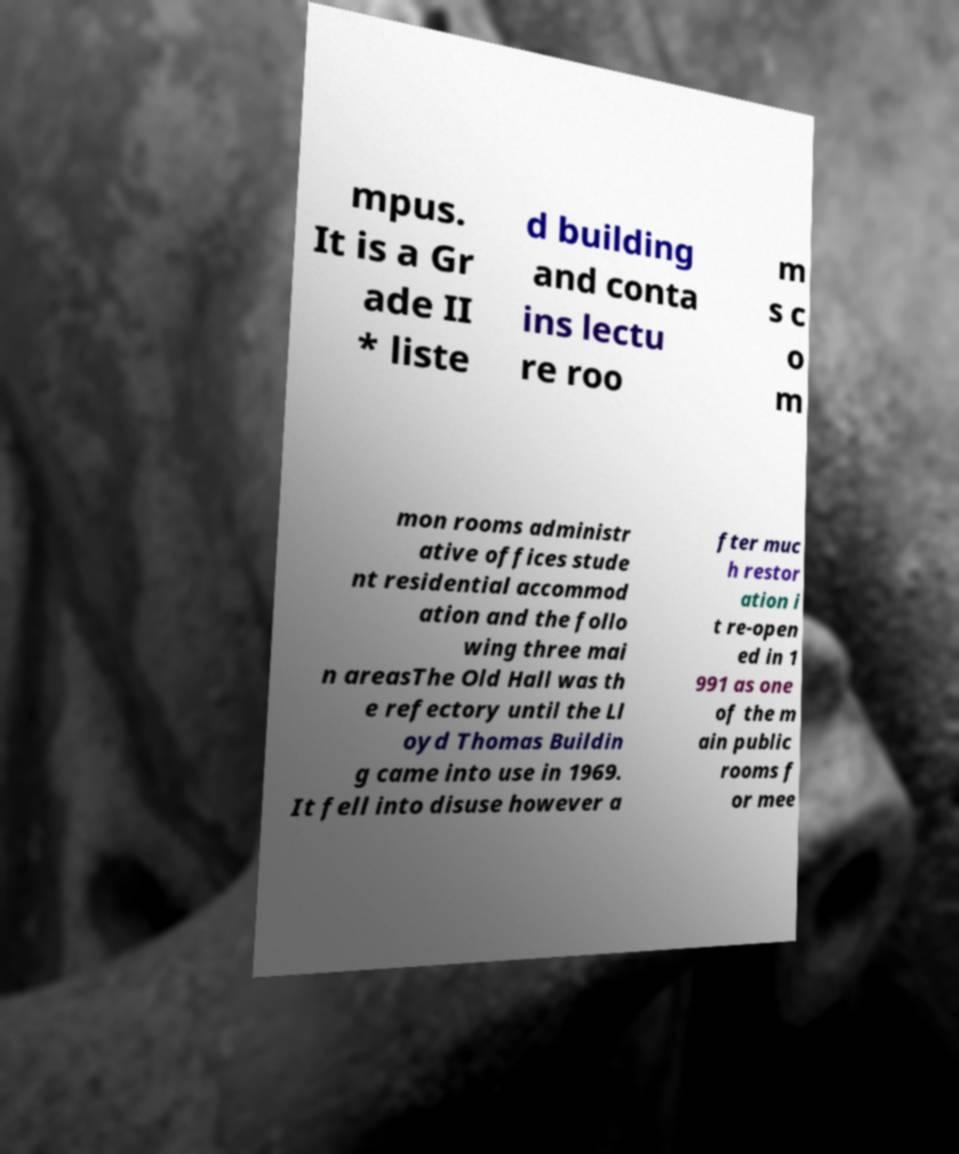Can you read and provide the text displayed in the image?This photo seems to have some interesting text. Can you extract and type it out for me? mpus. It is a Gr ade II * liste d building and conta ins lectu re roo m s c o m mon rooms administr ative offices stude nt residential accommod ation and the follo wing three mai n areasThe Old Hall was th e refectory until the Ll oyd Thomas Buildin g came into use in 1969. It fell into disuse however a fter muc h restor ation i t re-open ed in 1 991 as one of the m ain public rooms f or mee 